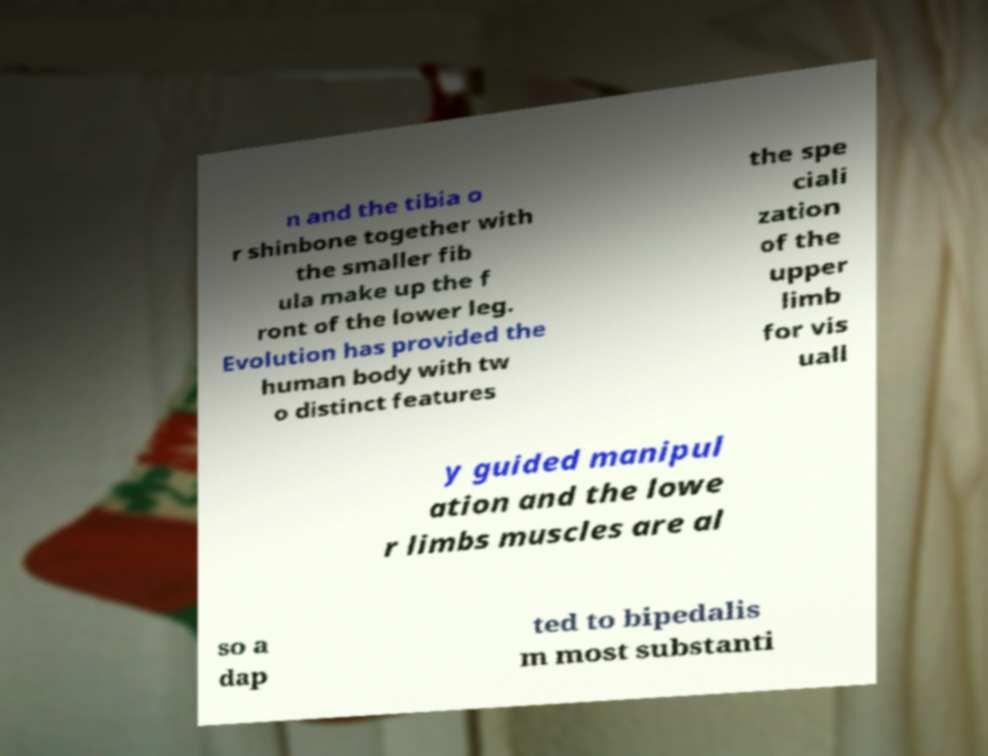For documentation purposes, I need the text within this image transcribed. Could you provide that? n and the tibia o r shinbone together with the smaller fib ula make up the f ront of the lower leg. Evolution has provided the human body with tw o distinct features the spe ciali zation of the upper limb for vis uall y guided manipul ation and the lowe r limbs muscles are al so a dap ted to bipedalis m most substanti 